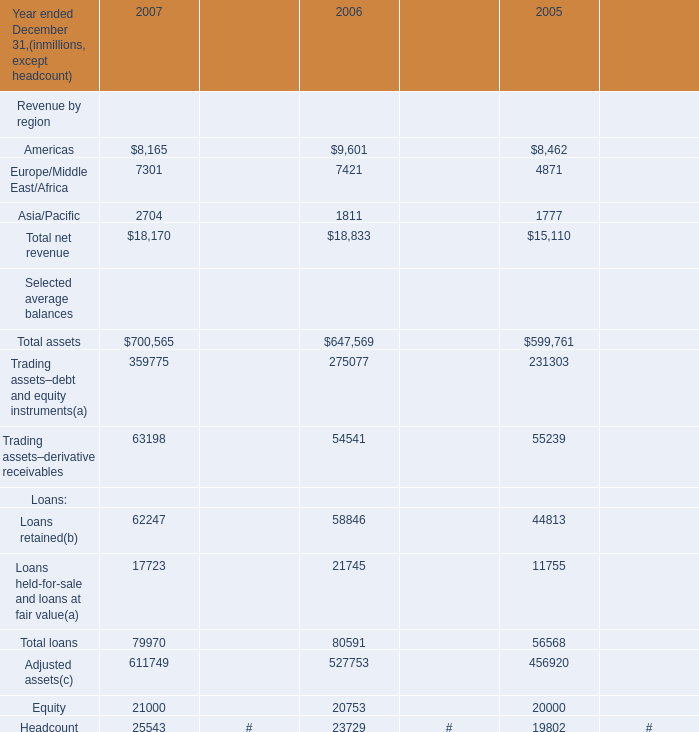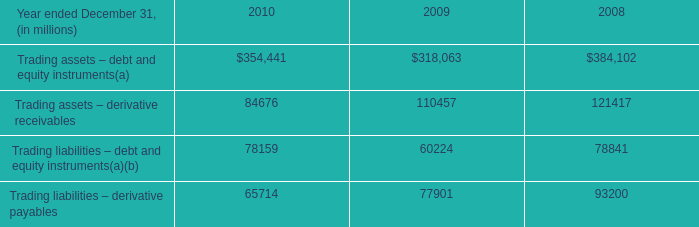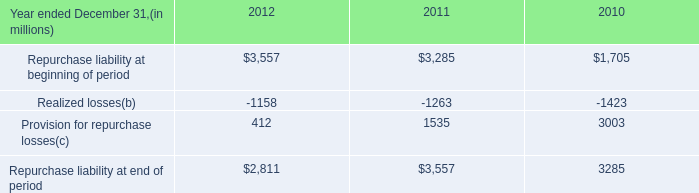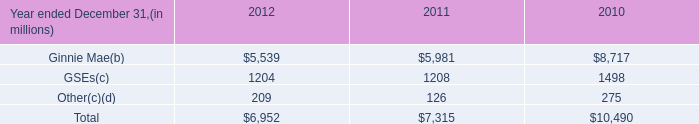What's the sum of the Repurchase liability at beginning of period in the years where Ginnie Mae(b) is greater than 5000? 
Computations: ((3557 + 3285) + 1705)
Answer: 8547.0. 